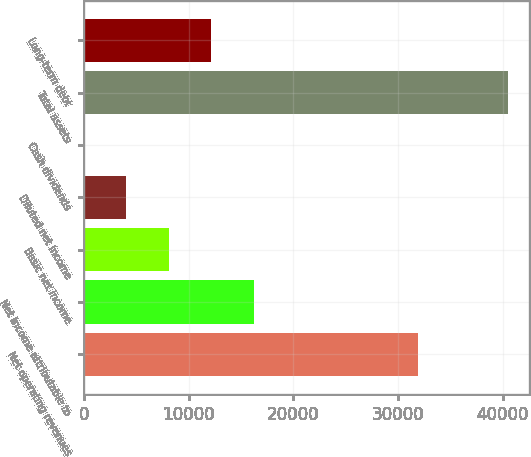Convert chart to OTSL. <chart><loc_0><loc_0><loc_500><loc_500><bar_chart><fcel>Net operating revenues<fcel>Net income attributable to<fcel>Basic net income<fcel>Diluted net income<fcel>Cash dividends<fcel>Total assets<fcel>Long-term debt<nl><fcel>31944<fcel>16208<fcel>8104.4<fcel>4052.58<fcel>0.76<fcel>40519<fcel>12156.2<nl></chart> 